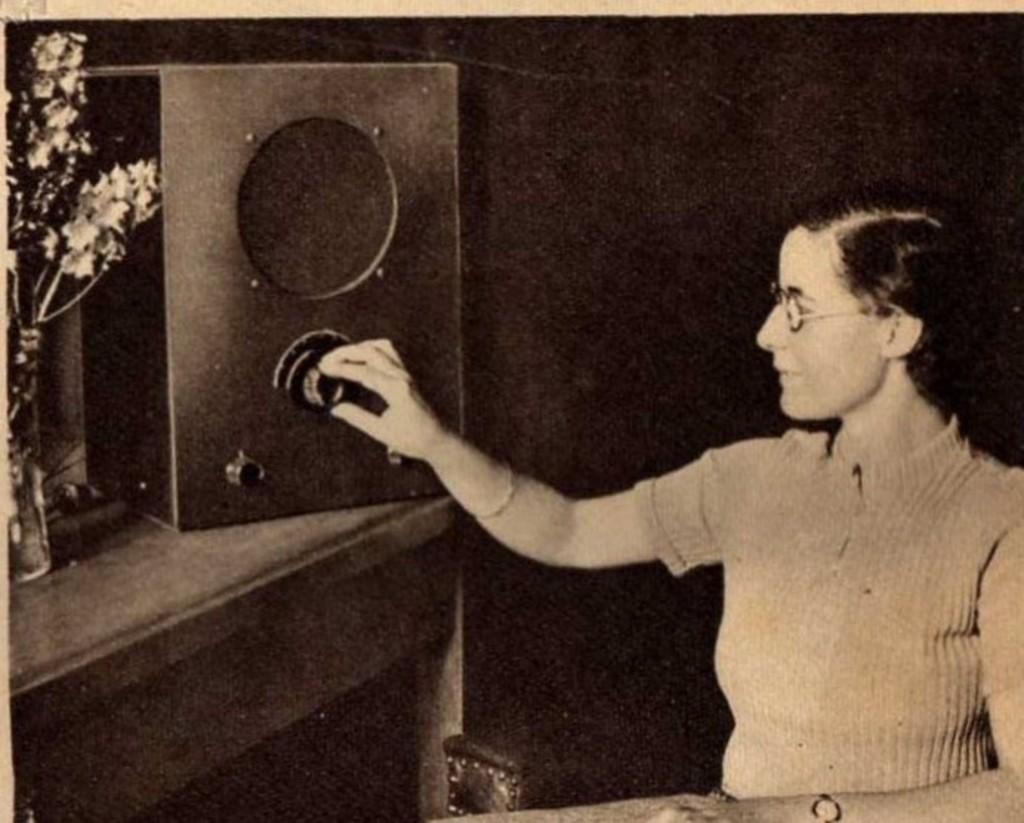Describe this image in one or two sentences. In this picture I can see a woman in front, who is holding the speaker knob and I see that, the speaker is on a table and I can see a flower vase near to the speaker and I see that she is wearing spectacle. 